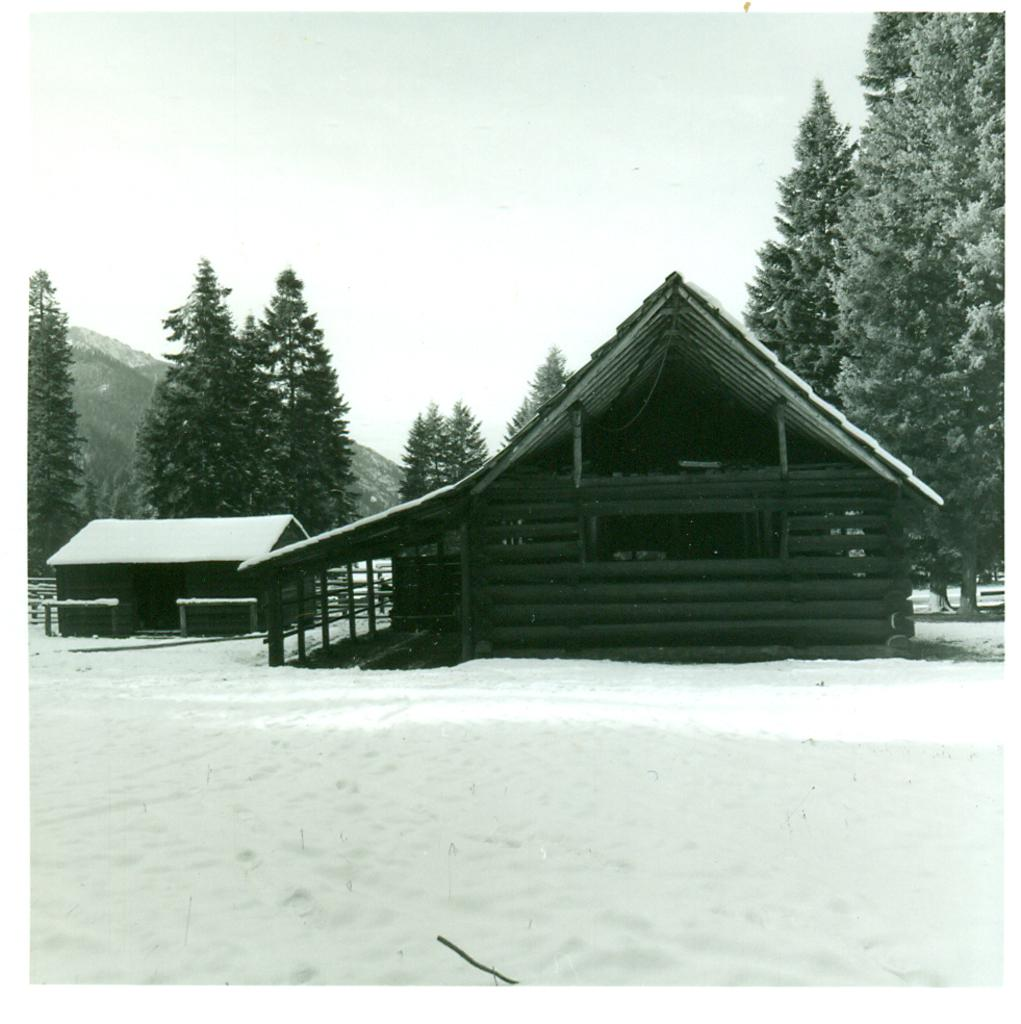How many wooden houses are in the image? There are two wooden houses in the image. What is covering the wooden houses? The wooden houses are covered with snow. What can be seen in the background of the image? There are trees in the background of the image. What type of pizzas are being served at the wooden houses in the image? There is no mention of pizzas in the image; it only shows two wooden houses covered with snow and trees in the background. 